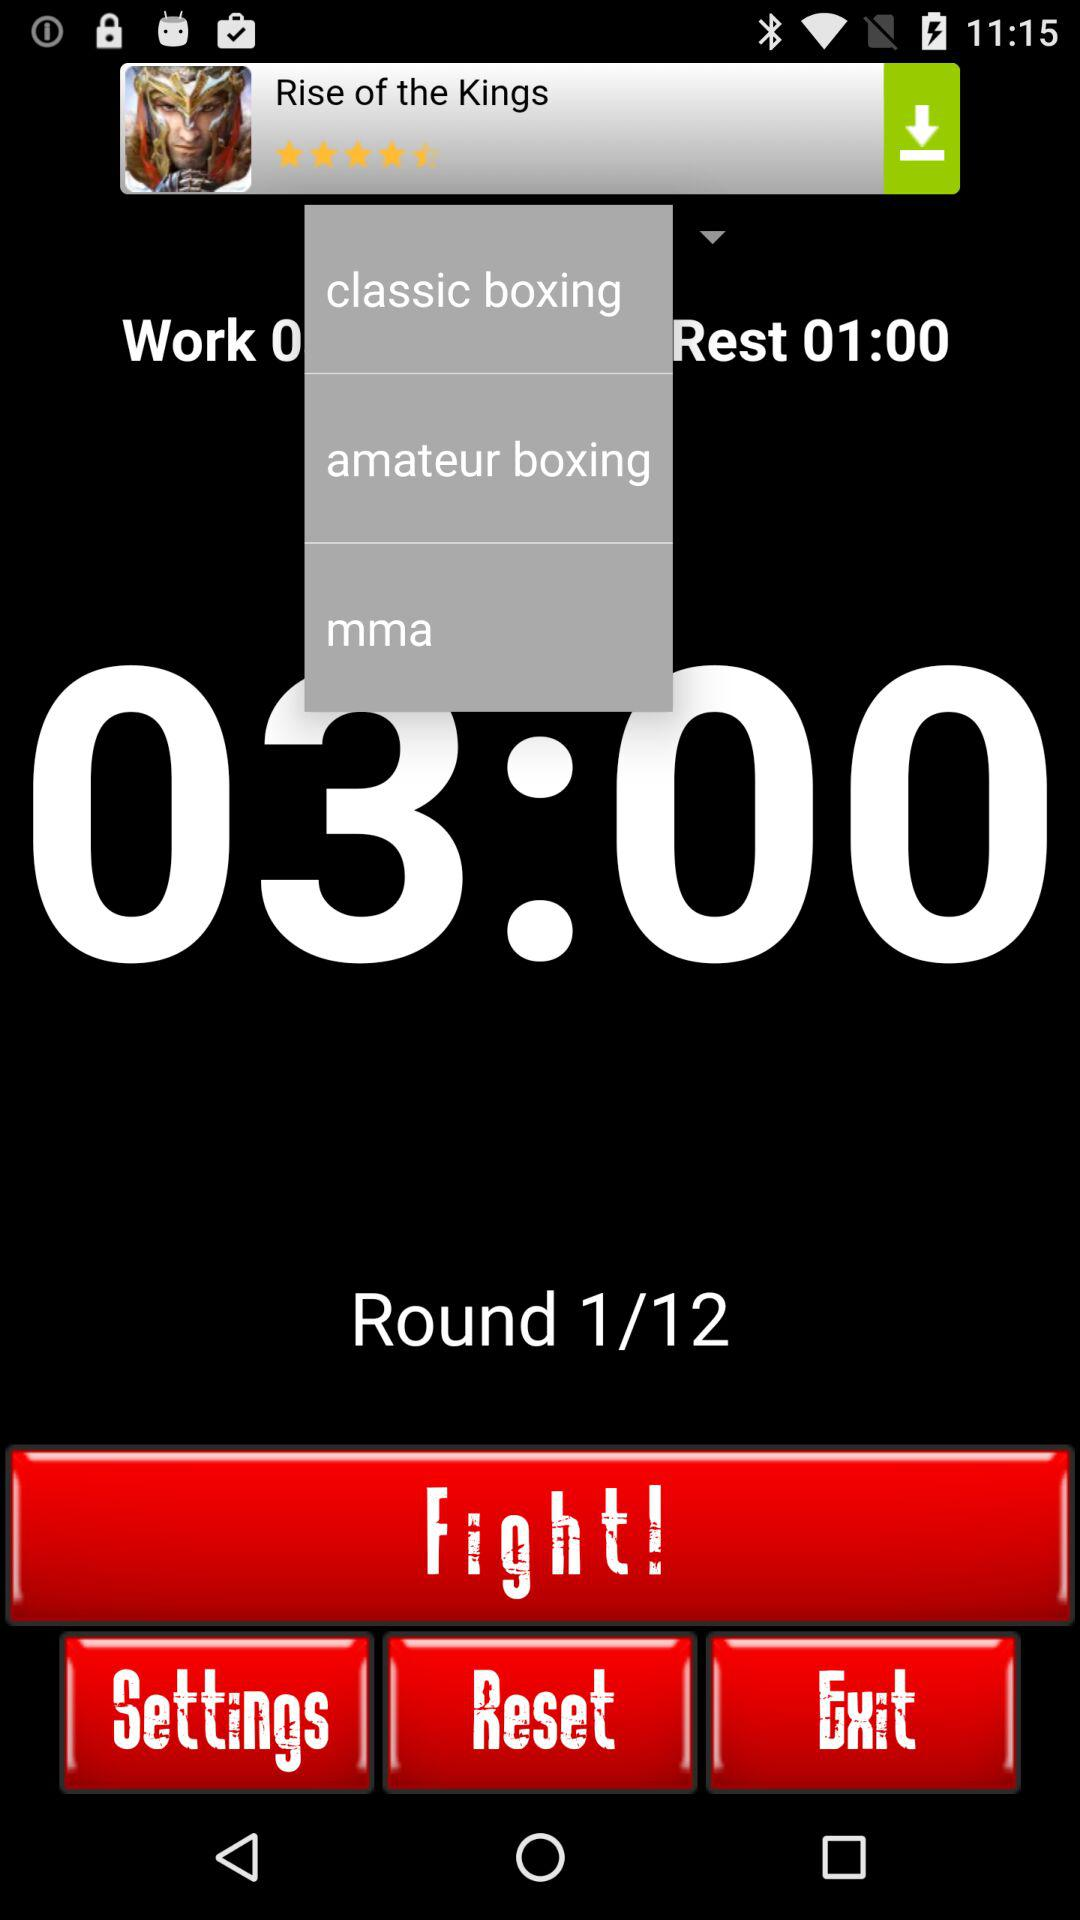How many rounds are in the fight?
Answer the question using a single word or phrase. 12 